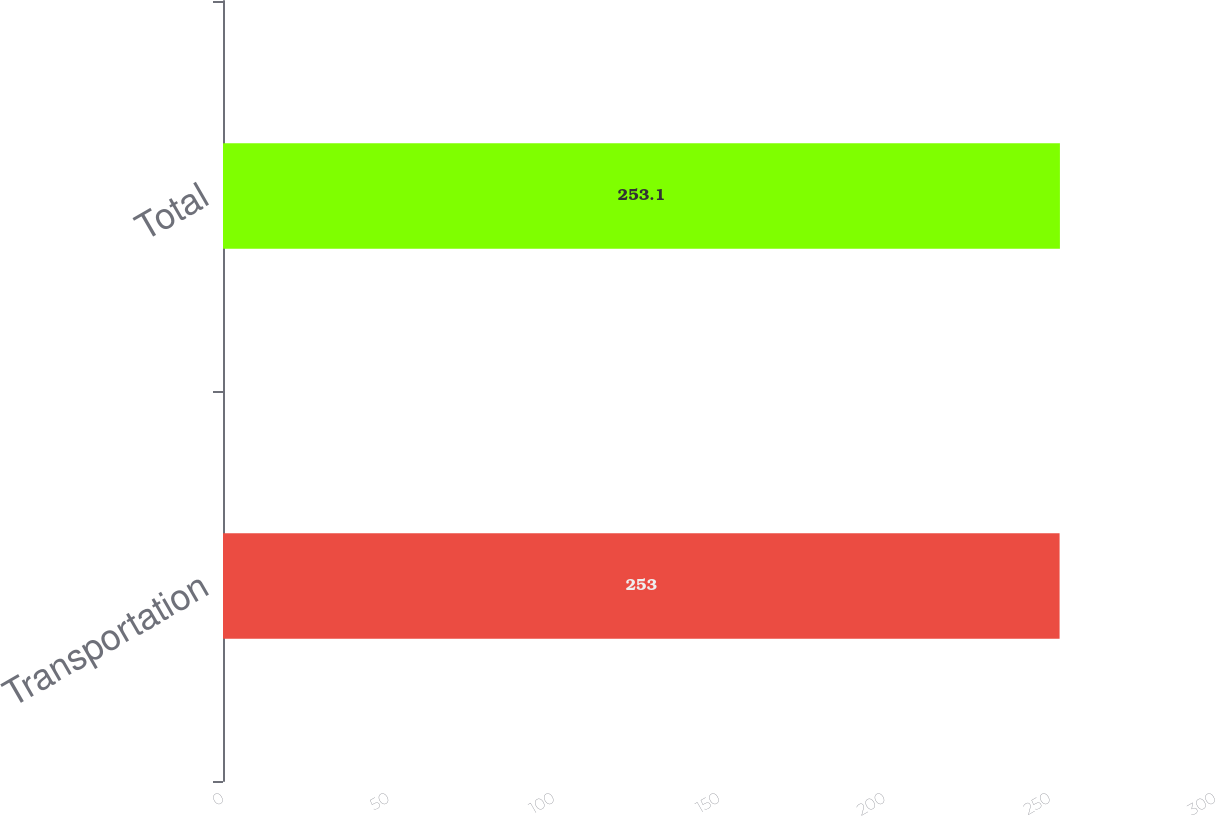Convert chart to OTSL. <chart><loc_0><loc_0><loc_500><loc_500><bar_chart><fcel>Transportation<fcel>Total<nl><fcel>253<fcel>253.1<nl></chart> 